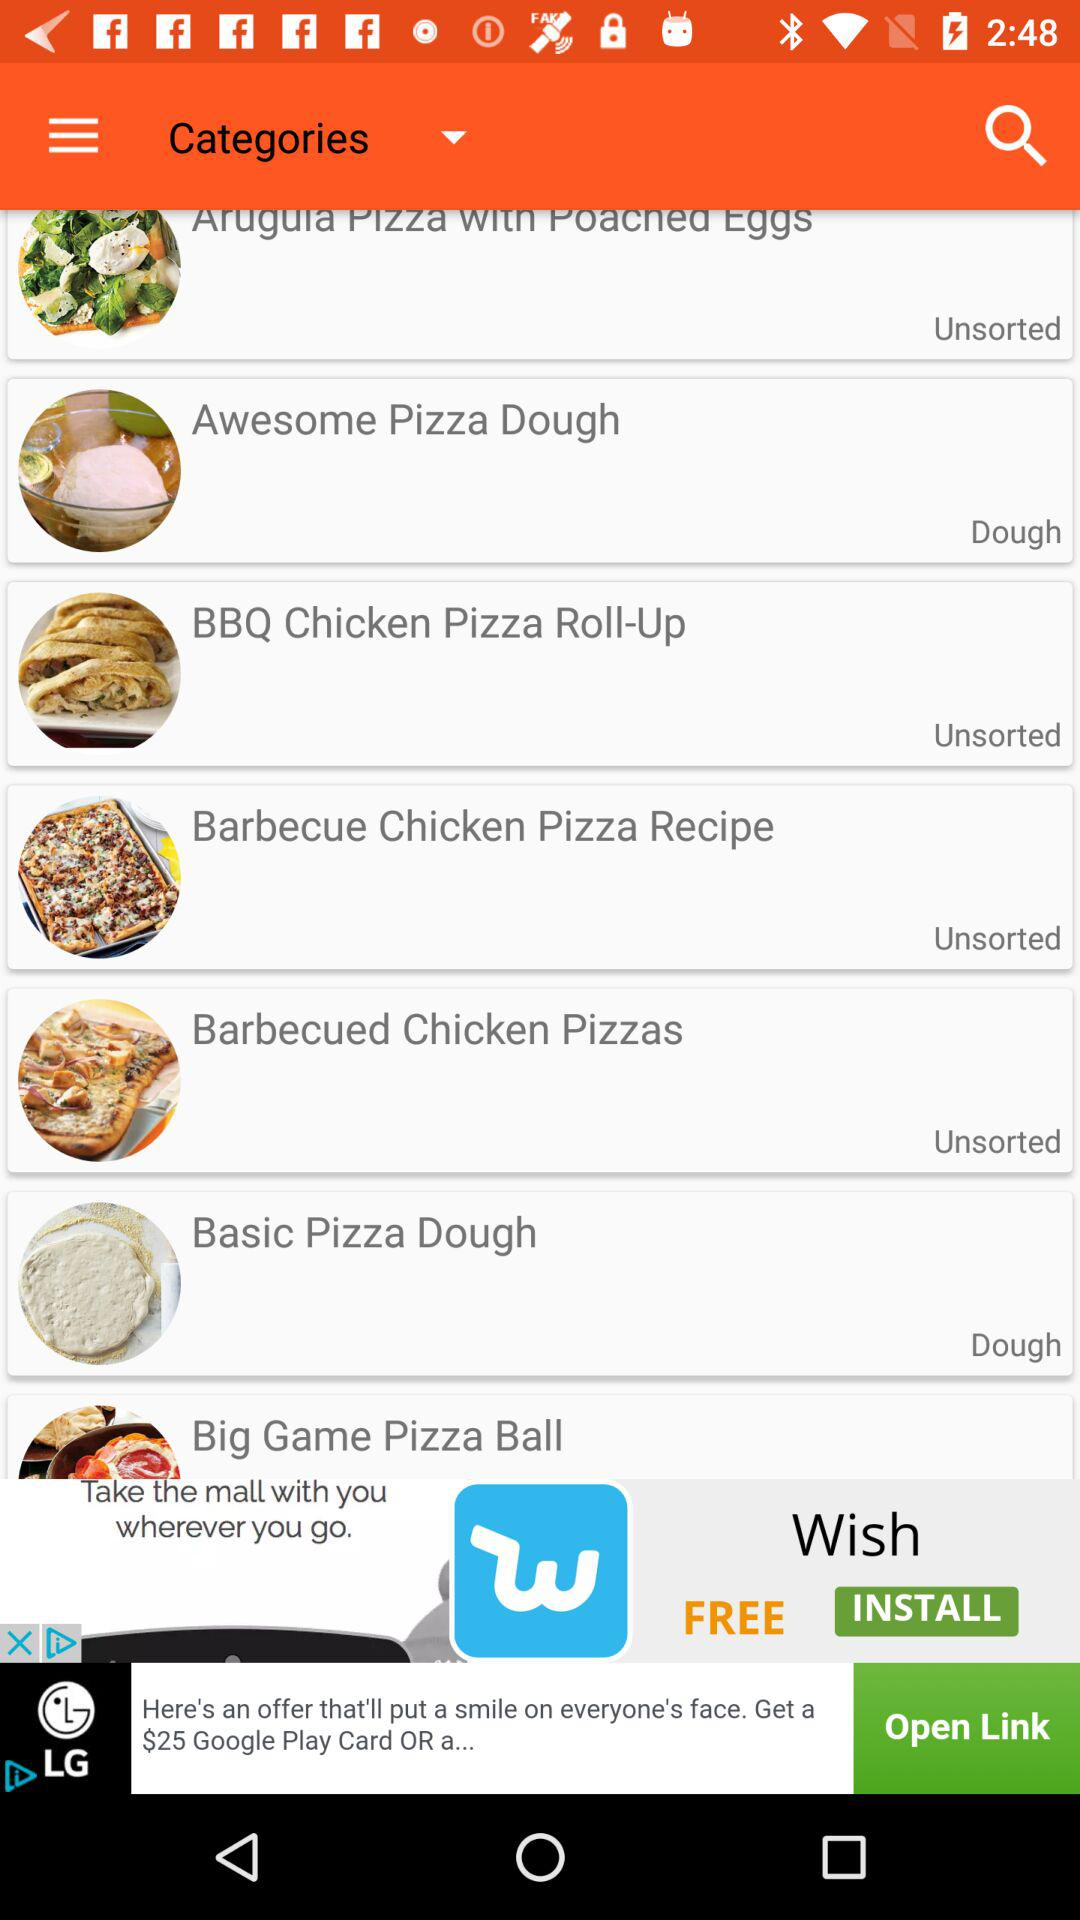Which recipe is for dough? The recipes for dough are "Awesome Pizza Dough" and "Basic Pizza Dough". 